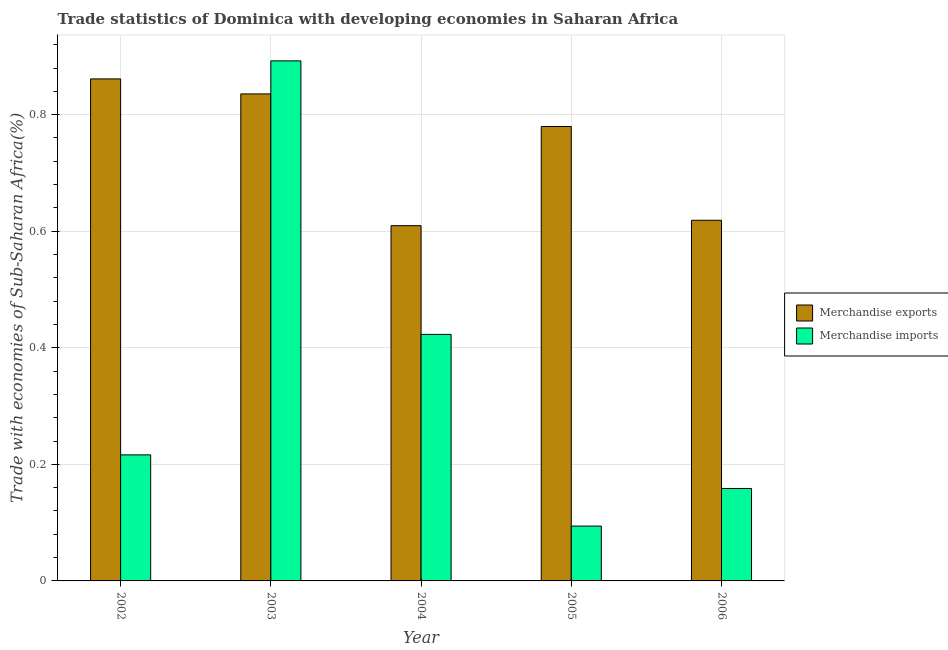How many groups of bars are there?
Make the answer very short. 5. Are the number of bars on each tick of the X-axis equal?
Ensure brevity in your answer.  Yes. How many bars are there on the 3rd tick from the left?
Offer a terse response. 2. How many bars are there on the 3rd tick from the right?
Make the answer very short. 2. What is the label of the 2nd group of bars from the left?
Provide a short and direct response. 2003. What is the merchandise imports in 2003?
Offer a very short reply. 0.89. Across all years, what is the maximum merchandise exports?
Offer a terse response. 0.86. Across all years, what is the minimum merchandise imports?
Make the answer very short. 0.09. In which year was the merchandise imports maximum?
Keep it short and to the point. 2003. What is the total merchandise exports in the graph?
Keep it short and to the point. 3.7. What is the difference between the merchandise exports in 2002 and that in 2006?
Give a very brief answer. 0.24. What is the difference between the merchandise exports in 2006 and the merchandise imports in 2002?
Your response must be concise. -0.24. What is the average merchandise exports per year?
Make the answer very short. 0.74. In the year 2002, what is the difference between the merchandise exports and merchandise imports?
Your response must be concise. 0. In how many years, is the merchandise exports greater than 0.8 %?
Offer a terse response. 2. What is the ratio of the merchandise exports in 2002 to that in 2006?
Your response must be concise. 1.39. Is the merchandise exports in 2003 less than that in 2004?
Offer a very short reply. No. What is the difference between the highest and the second highest merchandise exports?
Ensure brevity in your answer.  0.03. What is the difference between the highest and the lowest merchandise imports?
Provide a succinct answer. 0.8. In how many years, is the merchandise imports greater than the average merchandise imports taken over all years?
Make the answer very short. 2. Is the sum of the merchandise imports in 2002 and 2003 greater than the maximum merchandise exports across all years?
Your response must be concise. Yes. What does the 2nd bar from the left in 2003 represents?
Your answer should be compact. Merchandise imports. How many bars are there?
Keep it short and to the point. 10. What is the difference between two consecutive major ticks on the Y-axis?
Make the answer very short. 0.2. Are the values on the major ticks of Y-axis written in scientific E-notation?
Provide a short and direct response. No. How many legend labels are there?
Provide a short and direct response. 2. How are the legend labels stacked?
Offer a very short reply. Vertical. What is the title of the graph?
Give a very brief answer. Trade statistics of Dominica with developing economies in Saharan Africa. Does "Private funds" appear as one of the legend labels in the graph?
Make the answer very short. No. What is the label or title of the Y-axis?
Keep it short and to the point. Trade with economies of Sub-Saharan Africa(%). What is the Trade with economies of Sub-Saharan Africa(%) of Merchandise exports in 2002?
Provide a succinct answer. 0.86. What is the Trade with economies of Sub-Saharan Africa(%) of Merchandise imports in 2002?
Your response must be concise. 0.22. What is the Trade with economies of Sub-Saharan Africa(%) of Merchandise exports in 2003?
Your answer should be compact. 0.84. What is the Trade with economies of Sub-Saharan Africa(%) of Merchandise imports in 2003?
Your response must be concise. 0.89. What is the Trade with economies of Sub-Saharan Africa(%) in Merchandise exports in 2004?
Keep it short and to the point. 0.61. What is the Trade with economies of Sub-Saharan Africa(%) in Merchandise imports in 2004?
Your response must be concise. 0.42. What is the Trade with economies of Sub-Saharan Africa(%) in Merchandise exports in 2005?
Make the answer very short. 0.78. What is the Trade with economies of Sub-Saharan Africa(%) in Merchandise imports in 2005?
Offer a terse response. 0.09. What is the Trade with economies of Sub-Saharan Africa(%) of Merchandise exports in 2006?
Provide a succinct answer. 0.62. What is the Trade with economies of Sub-Saharan Africa(%) of Merchandise imports in 2006?
Your answer should be very brief. 0.16. Across all years, what is the maximum Trade with economies of Sub-Saharan Africa(%) of Merchandise exports?
Offer a very short reply. 0.86. Across all years, what is the maximum Trade with economies of Sub-Saharan Africa(%) of Merchandise imports?
Your answer should be very brief. 0.89. Across all years, what is the minimum Trade with economies of Sub-Saharan Africa(%) of Merchandise exports?
Keep it short and to the point. 0.61. Across all years, what is the minimum Trade with economies of Sub-Saharan Africa(%) in Merchandise imports?
Provide a succinct answer. 0.09. What is the total Trade with economies of Sub-Saharan Africa(%) in Merchandise exports in the graph?
Keep it short and to the point. 3.7. What is the total Trade with economies of Sub-Saharan Africa(%) of Merchandise imports in the graph?
Give a very brief answer. 1.78. What is the difference between the Trade with economies of Sub-Saharan Africa(%) of Merchandise exports in 2002 and that in 2003?
Make the answer very short. 0.03. What is the difference between the Trade with economies of Sub-Saharan Africa(%) in Merchandise imports in 2002 and that in 2003?
Your answer should be very brief. -0.68. What is the difference between the Trade with economies of Sub-Saharan Africa(%) of Merchandise exports in 2002 and that in 2004?
Offer a very short reply. 0.25. What is the difference between the Trade with economies of Sub-Saharan Africa(%) of Merchandise imports in 2002 and that in 2004?
Your answer should be very brief. -0.21. What is the difference between the Trade with economies of Sub-Saharan Africa(%) of Merchandise exports in 2002 and that in 2005?
Keep it short and to the point. 0.08. What is the difference between the Trade with economies of Sub-Saharan Africa(%) of Merchandise imports in 2002 and that in 2005?
Make the answer very short. 0.12. What is the difference between the Trade with economies of Sub-Saharan Africa(%) in Merchandise exports in 2002 and that in 2006?
Your answer should be very brief. 0.24. What is the difference between the Trade with economies of Sub-Saharan Africa(%) in Merchandise imports in 2002 and that in 2006?
Your answer should be compact. 0.06. What is the difference between the Trade with economies of Sub-Saharan Africa(%) of Merchandise exports in 2003 and that in 2004?
Provide a succinct answer. 0.23. What is the difference between the Trade with economies of Sub-Saharan Africa(%) in Merchandise imports in 2003 and that in 2004?
Your answer should be compact. 0.47. What is the difference between the Trade with economies of Sub-Saharan Africa(%) of Merchandise exports in 2003 and that in 2005?
Your response must be concise. 0.06. What is the difference between the Trade with economies of Sub-Saharan Africa(%) in Merchandise imports in 2003 and that in 2005?
Keep it short and to the point. 0.8. What is the difference between the Trade with economies of Sub-Saharan Africa(%) of Merchandise exports in 2003 and that in 2006?
Provide a short and direct response. 0.22. What is the difference between the Trade with economies of Sub-Saharan Africa(%) of Merchandise imports in 2003 and that in 2006?
Provide a succinct answer. 0.73. What is the difference between the Trade with economies of Sub-Saharan Africa(%) in Merchandise exports in 2004 and that in 2005?
Your response must be concise. -0.17. What is the difference between the Trade with economies of Sub-Saharan Africa(%) of Merchandise imports in 2004 and that in 2005?
Offer a very short reply. 0.33. What is the difference between the Trade with economies of Sub-Saharan Africa(%) of Merchandise exports in 2004 and that in 2006?
Provide a succinct answer. -0.01. What is the difference between the Trade with economies of Sub-Saharan Africa(%) of Merchandise imports in 2004 and that in 2006?
Provide a short and direct response. 0.26. What is the difference between the Trade with economies of Sub-Saharan Africa(%) in Merchandise exports in 2005 and that in 2006?
Provide a succinct answer. 0.16. What is the difference between the Trade with economies of Sub-Saharan Africa(%) of Merchandise imports in 2005 and that in 2006?
Make the answer very short. -0.06. What is the difference between the Trade with economies of Sub-Saharan Africa(%) of Merchandise exports in 2002 and the Trade with economies of Sub-Saharan Africa(%) of Merchandise imports in 2003?
Your answer should be very brief. -0.03. What is the difference between the Trade with economies of Sub-Saharan Africa(%) of Merchandise exports in 2002 and the Trade with economies of Sub-Saharan Africa(%) of Merchandise imports in 2004?
Give a very brief answer. 0.44. What is the difference between the Trade with economies of Sub-Saharan Africa(%) in Merchandise exports in 2002 and the Trade with economies of Sub-Saharan Africa(%) in Merchandise imports in 2005?
Keep it short and to the point. 0.77. What is the difference between the Trade with economies of Sub-Saharan Africa(%) of Merchandise exports in 2002 and the Trade with economies of Sub-Saharan Africa(%) of Merchandise imports in 2006?
Keep it short and to the point. 0.7. What is the difference between the Trade with economies of Sub-Saharan Africa(%) of Merchandise exports in 2003 and the Trade with economies of Sub-Saharan Africa(%) of Merchandise imports in 2004?
Your answer should be compact. 0.41. What is the difference between the Trade with economies of Sub-Saharan Africa(%) in Merchandise exports in 2003 and the Trade with economies of Sub-Saharan Africa(%) in Merchandise imports in 2005?
Provide a short and direct response. 0.74. What is the difference between the Trade with economies of Sub-Saharan Africa(%) of Merchandise exports in 2003 and the Trade with economies of Sub-Saharan Africa(%) of Merchandise imports in 2006?
Your answer should be very brief. 0.68. What is the difference between the Trade with economies of Sub-Saharan Africa(%) of Merchandise exports in 2004 and the Trade with economies of Sub-Saharan Africa(%) of Merchandise imports in 2005?
Your answer should be very brief. 0.52. What is the difference between the Trade with economies of Sub-Saharan Africa(%) in Merchandise exports in 2004 and the Trade with economies of Sub-Saharan Africa(%) in Merchandise imports in 2006?
Offer a terse response. 0.45. What is the difference between the Trade with economies of Sub-Saharan Africa(%) in Merchandise exports in 2005 and the Trade with economies of Sub-Saharan Africa(%) in Merchandise imports in 2006?
Ensure brevity in your answer.  0.62. What is the average Trade with economies of Sub-Saharan Africa(%) of Merchandise exports per year?
Provide a short and direct response. 0.74. What is the average Trade with economies of Sub-Saharan Africa(%) in Merchandise imports per year?
Offer a very short reply. 0.36. In the year 2002, what is the difference between the Trade with economies of Sub-Saharan Africa(%) in Merchandise exports and Trade with economies of Sub-Saharan Africa(%) in Merchandise imports?
Your answer should be compact. 0.65. In the year 2003, what is the difference between the Trade with economies of Sub-Saharan Africa(%) of Merchandise exports and Trade with economies of Sub-Saharan Africa(%) of Merchandise imports?
Your response must be concise. -0.06. In the year 2004, what is the difference between the Trade with economies of Sub-Saharan Africa(%) in Merchandise exports and Trade with economies of Sub-Saharan Africa(%) in Merchandise imports?
Your response must be concise. 0.19. In the year 2005, what is the difference between the Trade with economies of Sub-Saharan Africa(%) of Merchandise exports and Trade with economies of Sub-Saharan Africa(%) of Merchandise imports?
Make the answer very short. 0.69. In the year 2006, what is the difference between the Trade with economies of Sub-Saharan Africa(%) in Merchandise exports and Trade with economies of Sub-Saharan Africa(%) in Merchandise imports?
Your answer should be very brief. 0.46. What is the ratio of the Trade with economies of Sub-Saharan Africa(%) in Merchandise exports in 2002 to that in 2003?
Keep it short and to the point. 1.03. What is the ratio of the Trade with economies of Sub-Saharan Africa(%) of Merchandise imports in 2002 to that in 2003?
Ensure brevity in your answer.  0.24. What is the ratio of the Trade with economies of Sub-Saharan Africa(%) of Merchandise exports in 2002 to that in 2004?
Your answer should be very brief. 1.41. What is the ratio of the Trade with economies of Sub-Saharan Africa(%) of Merchandise imports in 2002 to that in 2004?
Your answer should be very brief. 0.51. What is the ratio of the Trade with economies of Sub-Saharan Africa(%) of Merchandise exports in 2002 to that in 2005?
Your response must be concise. 1.1. What is the ratio of the Trade with economies of Sub-Saharan Africa(%) of Merchandise imports in 2002 to that in 2005?
Ensure brevity in your answer.  2.3. What is the ratio of the Trade with economies of Sub-Saharan Africa(%) in Merchandise exports in 2002 to that in 2006?
Provide a succinct answer. 1.39. What is the ratio of the Trade with economies of Sub-Saharan Africa(%) in Merchandise imports in 2002 to that in 2006?
Ensure brevity in your answer.  1.36. What is the ratio of the Trade with economies of Sub-Saharan Africa(%) of Merchandise exports in 2003 to that in 2004?
Provide a short and direct response. 1.37. What is the ratio of the Trade with economies of Sub-Saharan Africa(%) of Merchandise imports in 2003 to that in 2004?
Your answer should be compact. 2.11. What is the ratio of the Trade with economies of Sub-Saharan Africa(%) of Merchandise exports in 2003 to that in 2005?
Your response must be concise. 1.07. What is the ratio of the Trade with economies of Sub-Saharan Africa(%) in Merchandise imports in 2003 to that in 2005?
Your answer should be compact. 9.48. What is the ratio of the Trade with economies of Sub-Saharan Africa(%) in Merchandise exports in 2003 to that in 2006?
Provide a short and direct response. 1.35. What is the ratio of the Trade with economies of Sub-Saharan Africa(%) of Merchandise imports in 2003 to that in 2006?
Keep it short and to the point. 5.63. What is the ratio of the Trade with economies of Sub-Saharan Africa(%) of Merchandise exports in 2004 to that in 2005?
Your response must be concise. 0.78. What is the ratio of the Trade with economies of Sub-Saharan Africa(%) in Merchandise imports in 2004 to that in 2005?
Provide a succinct answer. 4.5. What is the ratio of the Trade with economies of Sub-Saharan Africa(%) of Merchandise imports in 2004 to that in 2006?
Provide a short and direct response. 2.67. What is the ratio of the Trade with economies of Sub-Saharan Africa(%) in Merchandise exports in 2005 to that in 2006?
Keep it short and to the point. 1.26. What is the ratio of the Trade with economies of Sub-Saharan Africa(%) of Merchandise imports in 2005 to that in 2006?
Your response must be concise. 0.59. What is the difference between the highest and the second highest Trade with economies of Sub-Saharan Africa(%) in Merchandise exports?
Your answer should be very brief. 0.03. What is the difference between the highest and the second highest Trade with economies of Sub-Saharan Africa(%) of Merchandise imports?
Your answer should be compact. 0.47. What is the difference between the highest and the lowest Trade with economies of Sub-Saharan Africa(%) of Merchandise exports?
Provide a short and direct response. 0.25. What is the difference between the highest and the lowest Trade with economies of Sub-Saharan Africa(%) in Merchandise imports?
Provide a short and direct response. 0.8. 